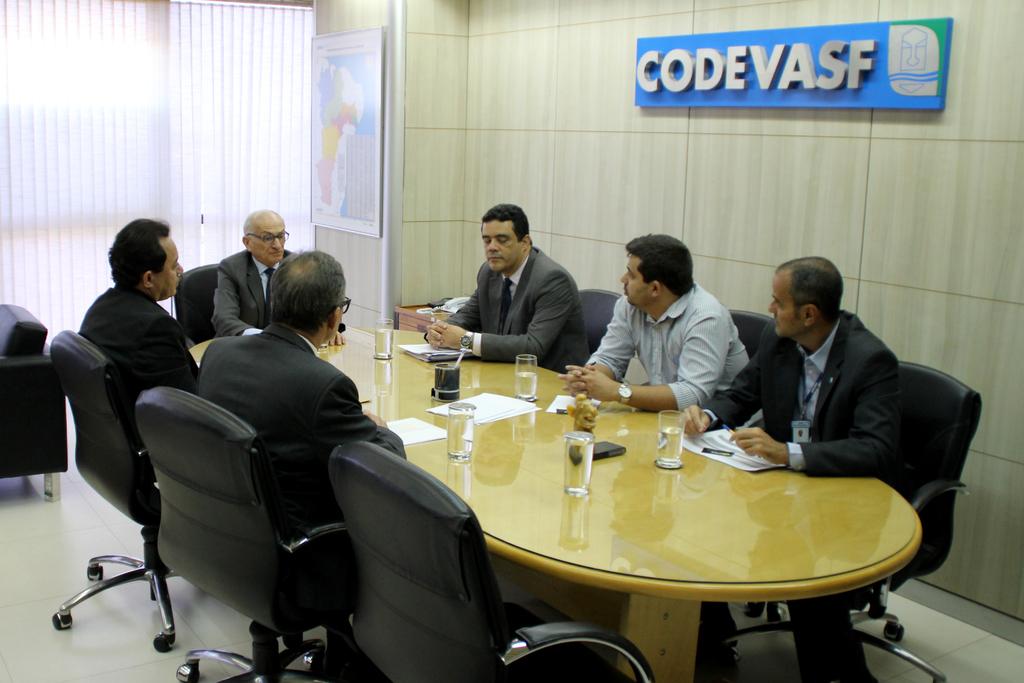What is on the sign?
Your answer should be compact. Codevasf. 